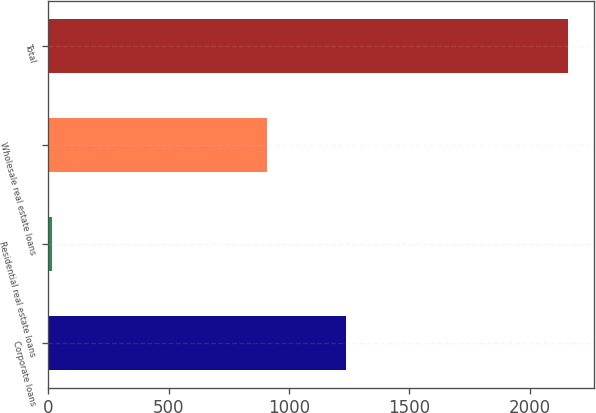Convert chart to OTSL. <chart><loc_0><loc_0><loc_500><loc_500><bar_chart><fcel>Corporate loans<fcel>Residential real estate loans<fcel>Wholesale real estate loans<fcel>Total<nl><fcel>1236<fcel>16<fcel>909<fcel>2161<nl></chart> 